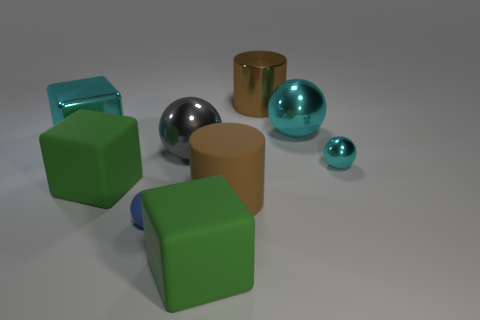Subtract all red balls. Subtract all red blocks. How many balls are left? 4 Subtract all cubes. How many objects are left? 6 Subtract all big green rubber cubes. Subtract all big brown metallic objects. How many objects are left? 6 Add 1 large rubber cubes. How many large rubber cubes are left? 3 Add 2 large metal blocks. How many large metal blocks exist? 3 Subtract 0 red blocks. How many objects are left? 9 